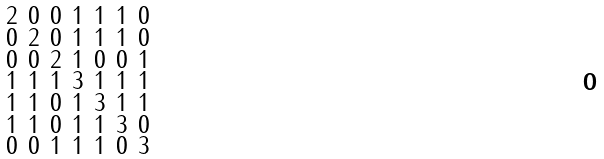Convert formula to latex. <formula><loc_0><loc_0><loc_500><loc_500>\begin{smallmatrix} 2 & 0 & 0 & 1 & 1 & 1 & 0 \\ 0 & 2 & 0 & 1 & 1 & 1 & 0 \\ 0 & 0 & 2 & 1 & 0 & 0 & 1 \\ 1 & 1 & 1 & 3 & 1 & 1 & 1 \\ 1 & 1 & 0 & 1 & 3 & 1 & 1 \\ 1 & 1 & 0 & 1 & 1 & 3 & 0 \\ 0 & 0 & 1 & 1 & 1 & 0 & 3 \end{smallmatrix}</formula> 